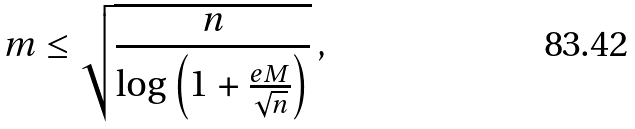<formula> <loc_0><loc_0><loc_500><loc_500>m \leq \sqrt { \frac { n } { \log \left ( 1 + \frac { e M } { \sqrt { n } } \right ) } } \, ,</formula> 